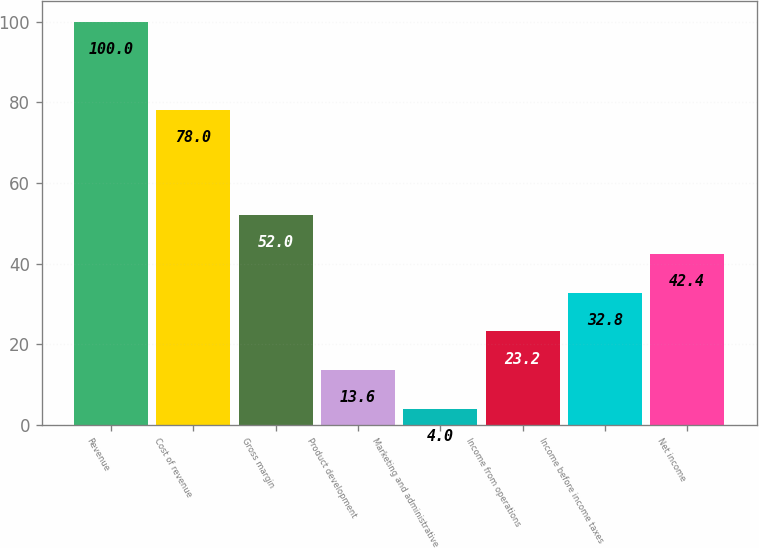<chart> <loc_0><loc_0><loc_500><loc_500><bar_chart><fcel>Revenue<fcel>Cost of revenue<fcel>Gross margin<fcel>Product development<fcel>Marketing and administrative<fcel>Income from operations<fcel>Income before income taxes<fcel>Net income<nl><fcel>100<fcel>78<fcel>52<fcel>13.6<fcel>4<fcel>23.2<fcel>32.8<fcel>42.4<nl></chart> 